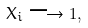<formula> <loc_0><loc_0><loc_500><loc_500>X _ { i } \longrightarrow 1 ,</formula> 